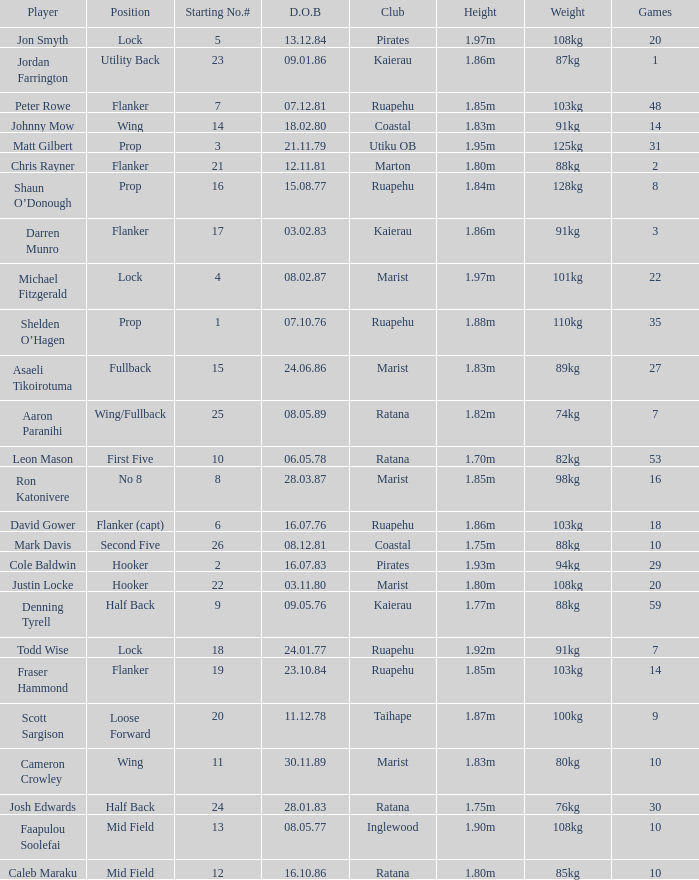What is the date of birth for the player in the Inglewood club? 80577.0. 